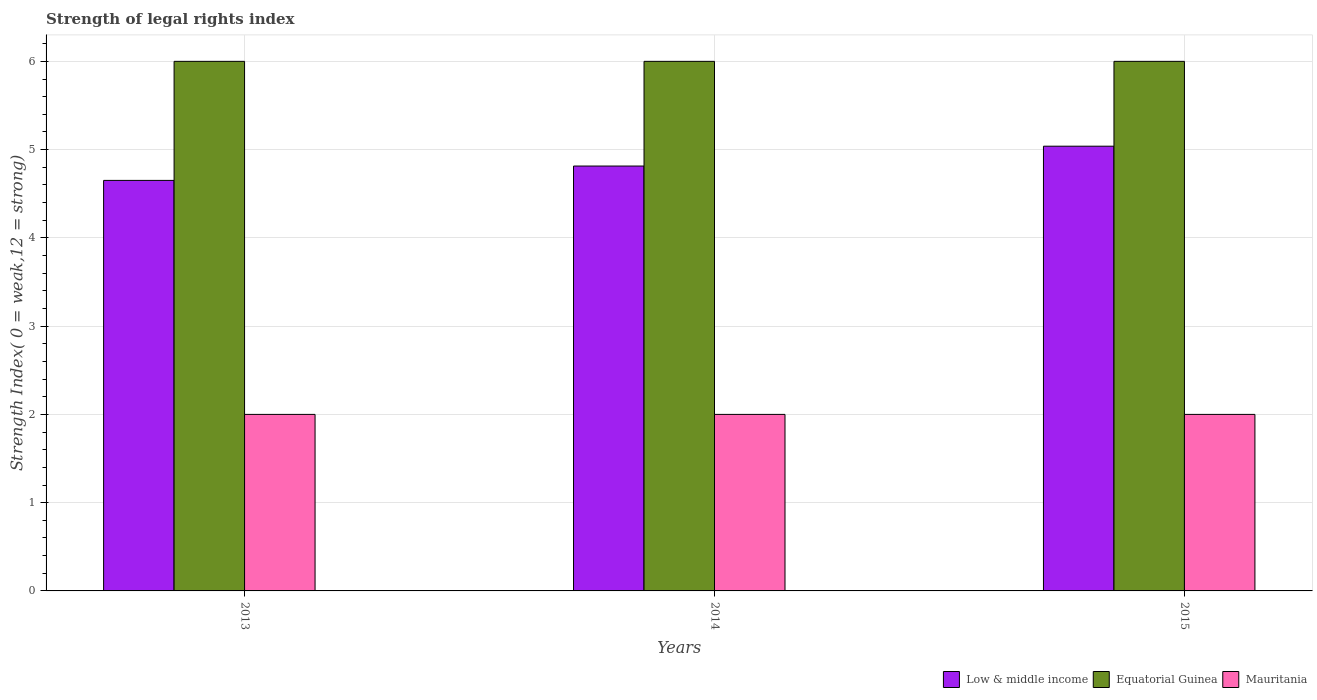How many groups of bars are there?
Your response must be concise. 3. How many bars are there on the 3rd tick from the right?
Your answer should be compact. 3. What is the label of the 2nd group of bars from the left?
Provide a succinct answer. 2014. What is the strength index in Low & middle income in 2014?
Provide a short and direct response. 4.81. Across all years, what is the maximum strength index in Low & middle income?
Make the answer very short. 5.04. Across all years, what is the minimum strength index in Low & middle income?
Your response must be concise. 4.65. In which year was the strength index in Equatorial Guinea maximum?
Keep it short and to the point. 2013. In which year was the strength index in Equatorial Guinea minimum?
Offer a terse response. 2013. What is the total strength index in Mauritania in the graph?
Your answer should be compact. 6. What is the difference between the strength index in Mauritania in 2014 and that in 2015?
Make the answer very short. 0. What is the difference between the strength index in Low & middle income in 2015 and the strength index in Equatorial Guinea in 2013?
Offer a terse response. -0.96. In the year 2013, what is the difference between the strength index in Low & middle income and strength index in Equatorial Guinea?
Offer a terse response. -1.35. In how many years, is the strength index in Mauritania greater than 1.2?
Offer a very short reply. 3. Is the difference between the strength index in Low & middle income in 2013 and 2015 greater than the difference between the strength index in Equatorial Guinea in 2013 and 2015?
Your answer should be very brief. No. What is the difference between the highest and the lowest strength index in Equatorial Guinea?
Your response must be concise. 0. What does the 3rd bar from the left in 2014 represents?
Provide a succinct answer. Mauritania. What does the 3rd bar from the right in 2014 represents?
Provide a succinct answer. Low & middle income. Is it the case that in every year, the sum of the strength index in Mauritania and strength index in Low & middle income is greater than the strength index in Equatorial Guinea?
Provide a short and direct response. Yes. How many bars are there?
Offer a very short reply. 9. Are all the bars in the graph horizontal?
Offer a terse response. No. What is the difference between two consecutive major ticks on the Y-axis?
Give a very brief answer. 1. Are the values on the major ticks of Y-axis written in scientific E-notation?
Offer a very short reply. No. Does the graph contain any zero values?
Give a very brief answer. No. How many legend labels are there?
Offer a terse response. 3. What is the title of the graph?
Give a very brief answer. Strength of legal rights index. What is the label or title of the Y-axis?
Your answer should be very brief. Strength Index( 0 = weak,12 = strong). What is the Strength Index( 0 = weak,12 = strong) in Low & middle income in 2013?
Offer a terse response. 4.65. What is the Strength Index( 0 = weak,12 = strong) of Equatorial Guinea in 2013?
Give a very brief answer. 6. What is the Strength Index( 0 = weak,12 = strong) of Low & middle income in 2014?
Keep it short and to the point. 4.81. What is the Strength Index( 0 = weak,12 = strong) in Equatorial Guinea in 2014?
Provide a succinct answer. 6. What is the Strength Index( 0 = weak,12 = strong) in Low & middle income in 2015?
Ensure brevity in your answer.  5.04. What is the Strength Index( 0 = weak,12 = strong) of Equatorial Guinea in 2015?
Ensure brevity in your answer.  6. What is the Strength Index( 0 = weak,12 = strong) in Mauritania in 2015?
Provide a short and direct response. 2. Across all years, what is the maximum Strength Index( 0 = weak,12 = strong) of Low & middle income?
Your answer should be compact. 5.04. Across all years, what is the maximum Strength Index( 0 = weak,12 = strong) in Equatorial Guinea?
Offer a terse response. 6. Across all years, what is the maximum Strength Index( 0 = weak,12 = strong) of Mauritania?
Your response must be concise. 2. Across all years, what is the minimum Strength Index( 0 = weak,12 = strong) of Low & middle income?
Offer a terse response. 4.65. Across all years, what is the minimum Strength Index( 0 = weak,12 = strong) in Equatorial Guinea?
Your answer should be very brief. 6. What is the total Strength Index( 0 = weak,12 = strong) in Low & middle income in the graph?
Ensure brevity in your answer.  14.5. What is the difference between the Strength Index( 0 = weak,12 = strong) in Low & middle income in 2013 and that in 2014?
Offer a terse response. -0.16. What is the difference between the Strength Index( 0 = weak,12 = strong) of Equatorial Guinea in 2013 and that in 2014?
Your answer should be very brief. 0. What is the difference between the Strength Index( 0 = weak,12 = strong) of Low & middle income in 2013 and that in 2015?
Keep it short and to the point. -0.39. What is the difference between the Strength Index( 0 = weak,12 = strong) of Equatorial Guinea in 2013 and that in 2015?
Give a very brief answer. 0. What is the difference between the Strength Index( 0 = weak,12 = strong) of Mauritania in 2013 and that in 2015?
Give a very brief answer. 0. What is the difference between the Strength Index( 0 = weak,12 = strong) in Low & middle income in 2014 and that in 2015?
Give a very brief answer. -0.22. What is the difference between the Strength Index( 0 = weak,12 = strong) in Mauritania in 2014 and that in 2015?
Your answer should be very brief. 0. What is the difference between the Strength Index( 0 = weak,12 = strong) of Low & middle income in 2013 and the Strength Index( 0 = weak,12 = strong) of Equatorial Guinea in 2014?
Provide a succinct answer. -1.35. What is the difference between the Strength Index( 0 = weak,12 = strong) in Low & middle income in 2013 and the Strength Index( 0 = weak,12 = strong) in Mauritania in 2014?
Your response must be concise. 2.65. What is the difference between the Strength Index( 0 = weak,12 = strong) of Equatorial Guinea in 2013 and the Strength Index( 0 = weak,12 = strong) of Mauritania in 2014?
Give a very brief answer. 4. What is the difference between the Strength Index( 0 = weak,12 = strong) of Low & middle income in 2013 and the Strength Index( 0 = weak,12 = strong) of Equatorial Guinea in 2015?
Offer a very short reply. -1.35. What is the difference between the Strength Index( 0 = weak,12 = strong) of Low & middle income in 2013 and the Strength Index( 0 = weak,12 = strong) of Mauritania in 2015?
Provide a succinct answer. 2.65. What is the difference between the Strength Index( 0 = weak,12 = strong) of Low & middle income in 2014 and the Strength Index( 0 = weak,12 = strong) of Equatorial Guinea in 2015?
Offer a terse response. -1.19. What is the difference between the Strength Index( 0 = weak,12 = strong) of Low & middle income in 2014 and the Strength Index( 0 = weak,12 = strong) of Mauritania in 2015?
Your response must be concise. 2.81. What is the difference between the Strength Index( 0 = weak,12 = strong) in Equatorial Guinea in 2014 and the Strength Index( 0 = weak,12 = strong) in Mauritania in 2015?
Your answer should be very brief. 4. What is the average Strength Index( 0 = weak,12 = strong) of Low & middle income per year?
Make the answer very short. 4.83. What is the average Strength Index( 0 = weak,12 = strong) in Mauritania per year?
Your response must be concise. 2. In the year 2013, what is the difference between the Strength Index( 0 = weak,12 = strong) in Low & middle income and Strength Index( 0 = weak,12 = strong) in Equatorial Guinea?
Your answer should be very brief. -1.35. In the year 2013, what is the difference between the Strength Index( 0 = weak,12 = strong) in Low & middle income and Strength Index( 0 = weak,12 = strong) in Mauritania?
Offer a very short reply. 2.65. In the year 2013, what is the difference between the Strength Index( 0 = weak,12 = strong) in Equatorial Guinea and Strength Index( 0 = weak,12 = strong) in Mauritania?
Your answer should be very brief. 4. In the year 2014, what is the difference between the Strength Index( 0 = weak,12 = strong) of Low & middle income and Strength Index( 0 = weak,12 = strong) of Equatorial Guinea?
Provide a short and direct response. -1.19. In the year 2014, what is the difference between the Strength Index( 0 = weak,12 = strong) in Low & middle income and Strength Index( 0 = weak,12 = strong) in Mauritania?
Provide a succinct answer. 2.81. In the year 2014, what is the difference between the Strength Index( 0 = weak,12 = strong) of Equatorial Guinea and Strength Index( 0 = weak,12 = strong) of Mauritania?
Make the answer very short. 4. In the year 2015, what is the difference between the Strength Index( 0 = weak,12 = strong) of Low & middle income and Strength Index( 0 = weak,12 = strong) of Equatorial Guinea?
Keep it short and to the point. -0.96. In the year 2015, what is the difference between the Strength Index( 0 = weak,12 = strong) in Low & middle income and Strength Index( 0 = weak,12 = strong) in Mauritania?
Provide a short and direct response. 3.04. In the year 2015, what is the difference between the Strength Index( 0 = weak,12 = strong) in Equatorial Guinea and Strength Index( 0 = weak,12 = strong) in Mauritania?
Offer a terse response. 4. What is the ratio of the Strength Index( 0 = weak,12 = strong) of Low & middle income in 2013 to that in 2014?
Make the answer very short. 0.97. What is the ratio of the Strength Index( 0 = weak,12 = strong) of Mauritania in 2013 to that in 2014?
Ensure brevity in your answer.  1. What is the ratio of the Strength Index( 0 = weak,12 = strong) in Low & middle income in 2013 to that in 2015?
Offer a terse response. 0.92. What is the ratio of the Strength Index( 0 = weak,12 = strong) of Mauritania in 2013 to that in 2015?
Offer a very short reply. 1. What is the ratio of the Strength Index( 0 = weak,12 = strong) of Low & middle income in 2014 to that in 2015?
Provide a succinct answer. 0.96. What is the ratio of the Strength Index( 0 = weak,12 = strong) in Mauritania in 2014 to that in 2015?
Provide a short and direct response. 1. What is the difference between the highest and the second highest Strength Index( 0 = weak,12 = strong) in Low & middle income?
Keep it short and to the point. 0.22. What is the difference between the highest and the second highest Strength Index( 0 = weak,12 = strong) in Equatorial Guinea?
Provide a short and direct response. 0. What is the difference between the highest and the lowest Strength Index( 0 = weak,12 = strong) in Low & middle income?
Offer a very short reply. 0.39. What is the difference between the highest and the lowest Strength Index( 0 = weak,12 = strong) of Mauritania?
Offer a terse response. 0. 